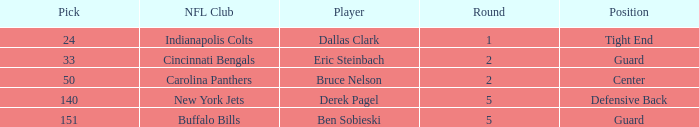During which round was a Hawkeyes player selected for the defensive back position? 5.0. Could you parse the entire table as a dict? {'header': ['Pick', 'NFL Club', 'Player', 'Round', 'Position'], 'rows': [['24', 'Indianapolis Colts', 'Dallas Clark', '1', 'Tight End'], ['33', 'Cincinnati Bengals', 'Eric Steinbach', '2', 'Guard'], ['50', 'Carolina Panthers', 'Bruce Nelson', '2', 'Center'], ['140', 'New York Jets', 'Derek Pagel', '5', 'Defensive Back'], ['151', 'Buffalo Bills', 'Ben Sobieski', '5', 'Guard']]} 